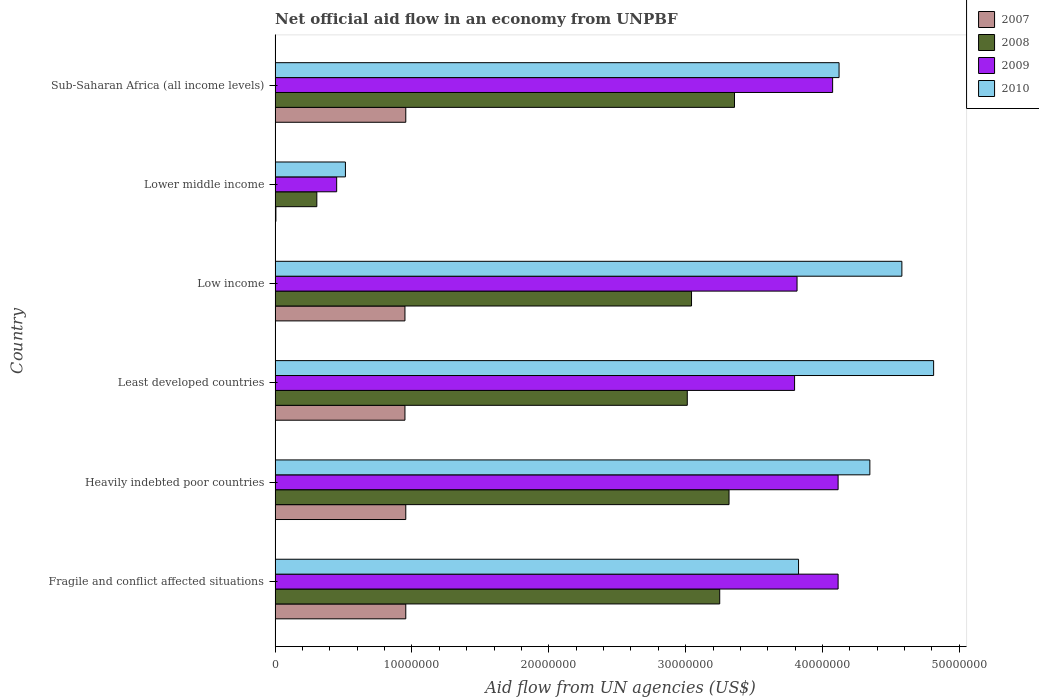Are the number of bars on each tick of the Y-axis equal?
Your answer should be very brief. Yes. How many bars are there on the 5th tick from the bottom?
Ensure brevity in your answer.  4. What is the label of the 2nd group of bars from the top?
Provide a succinct answer. Lower middle income. In how many cases, is the number of bars for a given country not equal to the number of legend labels?
Keep it short and to the point. 0. What is the net official aid flow in 2010 in Fragile and conflict affected situations?
Offer a terse response. 3.82e+07. Across all countries, what is the maximum net official aid flow in 2007?
Give a very brief answer. 9.55e+06. Across all countries, what is the minimum net official aid flow in 2010?
Your response must be concise. 5.14e+06. In which country was the net official aid flow in 2010 maximum?
Provide a succinct answer. Least developed countries. In which country was the net official aid flow in 2009 minimum?
Your answer should be compact. Lower middle income. What is the total net official aid flow in 2007 in the graph?
Ensure brevity in your answer.  4.77e+07. What is the difference between the net official aid flow in 2007 in Fragile and conflict affected situations and that in Low income?
Make the answer very short. 6.00e+04. What is the difference between the net official aid flow in 2010 in Fragile and conflict affected situations and the net official aid flow in 2008 in Least developed countries?
Keep it short and to the point. 8.13e+06. What is the average net official aid flow in 2010 per country?
Offer a very short reply. 3.70e+07. What is the difference between the net official aid flow in 2008 and net official aid flow in 2009 in Least developed countries?
Offer a terse response. -7.84e+06. What is the ratio of the net official aid flow in 2009 in Least developed countries to that in Lower middle income?
Give a very brief answer. 8.44. Is the difference between the net official aid flow in 2008 in Fragile and conflict affected situations and Low income greater than the difference between the net official aid flow in 2009 in Fragile and conflict affected situations and Low income?
Keep it short and to the point. No. What is the difference between the highest and the second highest net official aid flow in 2009?
Give a very brief answer. 0. What is the difference between the highest and the lowest net official aid flow in 2010?
Provide a succinct answer. 4.30e+07. In how many countries, is the net official aid flow in 2010 greater than the average net official aid flow in 2010 taken over all countries?
Offer a terse response. 5. Is the sum of the net official aid flow in 2010 in Fragile and conflict affected situations and Least developed countries greater than the maximum net official aid flow in 2009 across all countries?
Your answer should be very brief. Yes. Is it the case that in every country, the sum of the net official aid flow in 2009 and net official aid flow in 2008 is greater than the sum of net official aid flow in 2010 and net official aid flow in 2007?
Your response must be concise. No. What does the 3rd bar from the bottom in Lower middle income represents?
Your answer should be very brief. 2009. How many bars are there?
Provide a succinct answer. 24. What is the difference between two consecutive major ticks on the X-axis?
Offer a terse response. 1.00e+07. Are the values on the major ticks of X-axis written in scientific E-notation?
Keep it short and to the point. No. Where does the legend appear in the graph?
Provide a short and direct response. Top right. How many legend labels are there?
Ensure brevity in your answer.  4. How are the legend labels stacked?
Offer a terse response. Vertical. What is the title of the graph?
Offer a very short reply. Net official aid flow in an economy from UNPBF. What is the label or title of the X-axis?
Provide a short and direct response. Aid flow from UN agencies (US$). What is the Aid flow from UN agencies (US$) of 2007 in Fragile and conflict affected situations?
Your answer should be very brief. 9.55e+06. What is the Aid flow from UN agencies (US$) in 2008 in Fragile and conflict affected situations?
Keep it short and to the point. 3.25e+07. What is the Aid flow from UN agencies (US$) in 2009 in Fragile and conflict affected situations?
Give a very brief answer. 4.11e+07. What is the Aid flow from UN agencies (US$) of 2010 in Fragile and conflict affected situations?
Ensure brevity in your answer.  3.82e+07. What is the Aid flow from UN agencies (US$) in 2007 in Heavily indebted poor countries?
Offer a very short reply. 9.55e+06. What is the Aid flow from UN agencies (US$) in 2008 in Heavily indebted poor countries?
Provide a short and direct response. 3.32e+07. What is the Aid flow from UN agencies (US$) in 2009 in Heavily indebted poor countries?
Give a very brief answer. 4.11e+07. What is the Aid flow from UN agencies (US$) in 2010 in Heavily indebted poor countries?
Offer a very short reply. 4.35e+07. What is the Aid flow from UN agencies (US$) of 2007 in Least developed countries?
Ensure brevity in your answer.  9.49e+06. What is the Aid flow from UN agencies (US$) of 2008 in Least developed countries?
Your response must be concise. 3.01e+07. What is the Aid flow from UN agencies (US$) of 2009 in Least developed countries?
Give a very brief answer. 3.80e+07. What is the Aid flow from UN agencies (US$) of 2010 in Least developed countries?
Provide a short and direct response. 4.81e+07. What is the Aid flow from UN agencies (US$) of 2007 in Low income?
Provide a short and direct response. 9.49e+06. What is the Aid flow from UN agencies (US$) of 2008 in Low income?
Ensure brevity in your answer.  3.04e+07. What is the Aid flow from UN agencies (US$) in 2009 in Low income?
Keep it short and to the point. 3.81e+07. What is the Aid flow from UN agencies (US$) of 2010 in Low income?
Your answer should be very brief. 4.58e+07. What is the Aid flow from UN agencies (US$) in 2008 in Lower middle income?
Provide a short and direct response. 3.05e+06. What is the Aid flow from UN agencies (US$) in 2009 in Lower middle income?
Ensure brevity in your answer.  4.50e+06. What is the Aid flow from UN agencies (US$) in 2010 in Lower middle income?
Your answer should be very brief. 5.14e+06. What is the Aid flow from UN agencies (US$) of 2007 in Sub-Saharan Africa (all income levels)?
Make the answer very short. 9.55e+06. What is the Aid flow from UN agencies (US$) in 2008 in Sub-Saharan Africa (all income levels)?
Your answer should be compact. 3.36e+07. What is the Aid flow from UN agencies (US$) in 2009 in Sub-Saharan Africa (all income levels)?
Provide a succinct answer. 4.07e+07. What is the Aid flow from UN agencies (US$) of 2010 in Sub-Saharan Africa (all income levels)?
Offer a terse response. 4.12e+07. Across all countries, what is the maximum Aid flow from UN agencies (US$) in 2007?
Your answer should be compact. 9.55e+06. Across all countries, what is the maximum Aid flow from UN agencies (US$) in 2008?
Provide a succinct answer. 3.36e+07. Across all countries, what is the maximum Aid flow from UN agencies (US$) in 2009?
Offer a terse response. 4.11e+07. Across all countries, what is the maximum Aid flow from UN agencies (US$) of 2010?
Ensure brevity in your answer.  4.81e+07. Across all countries, what is the minimum Aid flow from UN agencies (US$) of 2007?
Offer a very short reply. 6.00e+04. Across all countries, what is the minimum Aid flow from UN agencies (US$) in 2008?
Offer a very short reply. 3.05e+06. Across all countries, what is the minimum Aid flow from UN agencies (US$) in 2009?
Provide a short and direct response. 4.50e+06. Across all countries, what is the minimum Aid flow from UN agencies (US$) in 2010?
Your answer should be very brief. 5.14e+06. What is the total Aid flow from UN agencies (US$) in 2007 in the graph?
Make the answer very short. 4.77e+07. What is the total Aid flow from UN agencies (US$) in 2008 in the graph?
Provide a short and direct response. 1.63e+08. What is the total Aid flow from UN agencies (US$) in 2009 in the graph?
Your response must be concise. 2.04e+08. What is the total Aid flow from UN agencies (US$) of 2010 in the graph?
Ensure brevity in your answer.  2.22e+08. What is the difference between the Aid flow from UN agencies (US$) of 2007 in Fragile and conflict affected situations and that in Heavily indebted poor countries?
Your answer should be very brief. 0. What is the difference between the Aid flow from UN agencies (US$) of 2008 in Fragile and conflict affected situations and that in Heavily indebted poor countries?
Give a very brief answer. -6.80e+05. What is the difference between the Aid flow from UN agencies (US$) in 2010 in Fragile and conflict affected situations and that in Heavily indebted poor countries?
Your answer should be compact. -5.21e+06. What is the difference between the Aid flow from UN agencies (US$) in 2008 in Fragile and conflict affected situations and that in Least developed countries?
Offer a very short reply. 2.37e+06. What is the difference between the Aid flow from UN agencies (US$) in 2009 in Fragile and conflict affected situations and that in Least developed countries?
Offer a terse response. 3.18e+06. What is the difference between the Aid flow from UN agencies (US$) of 2010 in Fragile and conflict affected situations and that in Least developed countries?
Offer a terse response. -9.87e+06. What is the difference between the Aid flow from UN agencies (US$) in 2008 in Fragile and conflict affected situations and that in Low income?
Offer a terse response. 2.06e+06. What is the difference between the Aid flow from UN agencies (US$) of 2009 in Fragile and conflict affected situations and that in Low income?
Your answer should be compact. 3.00e+06. What is the difference between the Aid flow from UN agencies (US$) of 2010 in Fragile and conflict affected situations and that in Low income?
Your response must be concise. -7.55e+06. What is the difference between the Aid flow from UN agencies (US$) in 2007 in Fragile and conflict affected situations and that in Lower middle income?
Keep it short and to the point. 9.49e+06. What is the difference between the Aid flow from UN agencies (US$) in 2008 in Fragile and conflict affected situations and that in Lower middle income?
Your answer should be compact. 2.94e+07. What is the difference between the Aid flow from UN agencies (US$) of 2009 in Fragile and conflict affected situations and that in Lower middle income?
Your answer should be compact. 3.66e+07. What is the difference between the Aid flow from UN agencies (US$) in 2010 in Fragile and conflict affected situations and that in Lower middle income?
Your answer should be compact. 3.31e+07. What is the difference between the Aid flow from UN agencies (US$) in 2007 in Fragile and conflict affected situations and that in Sub-Saharan Africa (all income levels)?
Your response must be concise. 0. What is the difference between the Aid flow from UN agencies (US$) in 2008 in Fragile and conflict affected situations and that in Sub-Saharan Africa (all income levels)?
Offer a very short reply. -1.08e+06. What is the difference between the Aid flow from UN agencies (US$) of 2009 in Fragile and conflict affected situations and that in Sub-Saharan Africa (all income levels)?
Give a very brief answer. 4.00e+05. What is the difference between the Aid flow from UN agencies (US$) in 2010 in Fragile and conflict affected situations and that in Sub-Saharan Africa (all income levels)?
Make the answer very short. -2.96e+06. What is the difference between the Aid flow from UN agencies (US$) in 2007 in Heavily indebted poor countries and that in Least developed countries?
Give a very brief answer. 6.00e+04. What is the difference between the Aid flow from UN agencies (US$) of 2008 in Heavily indebted poor countries and that in Least developed countries?
Give a very brief answer. 3.05e+06. What is the difference between the Aid flow from UN agencies (US$) of 2009 in Heavily indebted poor countries and that in Least developed countries?
Offer a very short reply. 3.18e+06. What is the difference between the Aid flow from UN agencies (US$) in 2010 in Heavily indebted poor countries and that in Least developed countries?
Provide a short and direct response. -4.66e+06. What is the difference between the Aid flow from UN agencies (US$) in 2007 in Heavily indebted poor countries and that in Low income?
Make the answer very short. 6.00e+04. What is the difference between the Aid flow from UN agencies (US$) in 2008 in Heavily indebted poor countries and that in Low income?
Keep it short and to the point. 2.74e+06. What is the difference between the Aid flow from UN agencies (US$) of 2010 in Heavily indebted poor countries and that in Low income?
Your response must be concise. -2.34e+06. What is the difference between the Aid flow from UN agencies (US$) in 2007 in Heavily indebted poor countries and that in Lower middle income?
Your response must be concise. 9.49e+06. What is the difference between the Aid flow from UN agencies (US$) in 2008 in Heavily indebted poor countries and that in Lower middle income?
Your answer should be very brief. 3.01e+07. What is the difference between the Aid flow from UN agencies (US$) of 2009 in Heavily indebted poor countries and that in Lower middle income?
Make the answer very short. 3.66e+07. What is the difference between the Aid flow from UN agencies (US$) in 2010 in Heavily indebted poor countries and that in Lower middle income?
Your answer should be very brief. 3.83e+07. What is the difference between the Aid flow from UN agencies (US$) in 2008 in Heavily indebted poor countries and that in Sub-Saharan Africa (all income levels)?
Your response must be concise. -4.00e+05. What is the difference between the Aid flow from UN agencies (US$) of 2010 in Heavily indebted poor countries and that in Sub-Saharan Africa (all income levels)?
Your answer should be very brief. 2.25e+06. What is the difference between the Aid flow from UN agencies (US$) of 2008 in Least developed countries and that in Low income?
Your response must be concise. -3.10e+05. What is the difference between the Aid flow from UN agencies (US$) in 2009 in Least developed countries and that in Low income?
Keep it short and to the point. -1.80e+05. What is the difference between the Aid flow from UN agencies (US$) in 2010 in Least developed countries and that in Low income?
Ensure brevity in your answer.  2.32e+06. What is the difference between the Aid flow from UN agencies (US$) in 2007 in Least developed countries and that in Lower middle income?
Ensure brevity in your answer.  9.43e+06. What is the difference between the Aid flow from UN agencies (US$) of 2008 in Least developed countries and that in Lower middle income?
Your answer should be very brief. 2.71e+07. What is the difference between the Aid flow from UN agencies (US$) of 2009 in Least developed countries and that in Lower middle income?
Provide a short and direct response. 3.35e+07. What is the difference between the Aid flow from UN agencies (US$) of 2010 in Least developed countries and that in Lower middle income?
Keep it short and to the point. 4.30e+07. What is the difference between the Aid flow from UN agencies (US$) in 2007 in Least developed countries and that in Sub-Saharan Africa (all income levels)?
Give a very brief answer. -6.00e+04. What is the difference between the Aid flow from UN agencies (US$) in 2008 in Least developed countries and that in Sub-Saharan Africa (all income levels)?
Make the answer very short. -3.45e+06. What is the difference between the Aid flow from UN agencies (US$) in 2009 in Least developed countries and that in Sub-Saharan Africa (all income levels)?
Your response must be concise. -2.78e+06. What is the difference between the Aid flow from UN agencies (US$) of 2010 in Least developed countries and that in Sub-Saharan Africa (all income levels)?
Provide a short and direct response. 6.91e+06. What is the difference between the Aid flow from UN agencies (US$) of 2007 in Low income and that in Lower middle income?
Your answer should be compact. 9.43e+06. What is the difference between the Aid flow from UN agencies (US$) in 2008 in Low income and that in Lower middle income?
Your answer should be very brief. 2.74e+07. What is the difference between the Aid flow from UN agencies (US$) of 2009 in Low income and that in Lower middle income?
Ensure brevity in your answer.  3.36e+07. What is the difference between the Aid flow from UN agencies (US$) in 2010 in Low income and that in Lower middle income?
Provide a short and direct response. 4.07e+07. What is the difference between the Aid flow from UN agencies (US$) in 2008 in Low income and that in Sub-Saharan Africa (all income levels)?
Ensure brevity in your answer.  -3.14e+06. What is the difference between the Aid flow from UN agencies (US$) in 2009 in Low income and that in Sub-Saharan Africa (all income levels)?
Your answer should be compact. -2.60e+06. What is the difference between the Aid flow from UN agencies (US$) in 2010 in Low income and that in Sub-Saharan Africa (all income levels)?
Offer a very short reply. 4.59e+06. What is the difference between the Aid flow from UN agencies (US$) in 2007 in Lower middle income and that in Sub-Saharan Africa (all income levels)?
Give a very brief answer. -9.49e+06. What is the difference between the Aid flow from UN agencies (US$) of 2008 in Lower middle income and that in Sub-Saharan Africa (all income levels)?
Offer a terse response. -3.05e+07. What is the difference between the Aid flow from UN agencies (US$) in 2009 in Lower middle income and that in Sub-Saharan Africa (all income levels)?
Keep it short and to the point. -3.62e+07. What is the difference between the Aid flow from UN agencies (US$) of 2010 in Lower middle income and that in Sub-Saharan Africa (all income levels)?
Give a very brief answer. -3.61e+07. What is the difference between the Aid flow from UN agencies (US$) in 2007 in Fragile and conflict affected situations and the Aid flow from UN agencies (US$) in 2008 in Heavily indebted poor countries?
Provide a short and direct response. -2.36e+07. What is the difference between the Aid flow from UN agencies (US$) in 2007 in Fragile and conflict affected situations and the Aid flow from UN agencies (US$) in 2009 in Heavily indebted poor countries?
Your answer should be compact. -3.16e+07. What is the difference between the Aid flow from UN agencies (US$) in 2007 in Fragile and conflict affected situations and the Aid flow from UN agencies (US$) in 2010 in Heavily indebted poor countries?
Provide a short and direct response. -3.39e+07. What is the difference between the Aid flow from UN agencies (US$) of 2008 in Fragile and conflict affected situations and the Aid flow from UN agencies (US$) of 2009 in Heavily indebted poor countries?
Your response must be concise. -8.65e+06. What is the difference between the Aid flow from UN agencies (US$) of 2008 in Fragile and conflict affected situations and the Aid flow from UN agencies (US$) of 2010 in Heavily indebted poor countries?
Offer a terse response. -1.10e+07. What is the difference between the Aid flow from UN agencies (US$) of 2009 in Fragile and conflict affected situations and the Aid flow from UN agencies (US$) of 2010 in Heavily indebted poor countries?
Make the answer very short. -2.32e+06. What is the difference between the Aid flow from UN agencies (US$) in 2007 in Fragile and conflict affected situations and the Aid flow from UN agencies (US$) in 2008 in Least developed countries?
Give a very brief answer. -2.06e+07. What is the difference between the Aid flow from UN agencies (US$) in 2007 in Fragile and conflict affected situations and the Aid flow from UN agencies (US$) in 2009 in Least developed countries?
Your answer should be compact. -2.84e+07. What is the difference between the Aid flow from UN agencies (US$) of 2007 in Fragile and conflict affected situations and the Aid flow from UN agencies (US$) of 2010 in Least developed countries?
Offer a very short reply. -3.86e+07. What is the difference between the Aid flow from UN agencies (US$) of 2008 in Fragile and conflict affected situations and the Aid flow from UN agencies (US$) of 2009 in Least developed countries?
Provide a short and direct response. -5.47e+06. What is the difference between the Aid flow from UN agencies (US$) in 2008 in Fragile and conflict affected situations and the Aid flow from UN agencies (US$) in 2010 in Least developed countries?
Ensure brevity in your answer.  -1.56e+07. What is the difference between the Aid flow from UN agencies (US$) of 2009 in Fragile and conflict affected situations and the Aid flow from UN agencies (US$) of 2010 in Least developed countries?
Provide a short and direct response. -6.98e+06. What is the difference between the Aid flow from UN agencies (US$) of 2007 in Fragile and conflict affected situations and the Aid flow from UN agencies (US$) of 2008 in Low income?
Make the answer very short. -2.09e+07. What is the difference between the Aid flow from UN agencies (US$) in 2007 in Fragile and conflict affected situations and the Aid flow from UN agencies (US$) in 2009 in Low income?
Offer a very short reply. -2.86e+07. What is the difference between the Aid flow from UN agencies (US$) in 2007 in Fragile and conflict affected situations and the Aid flow from UN agencies (US$) in 2010 in Low income?
Your answer should be compact. -3.62e+07. What is the difference between the Aid flow from UN agencies (US$) in 2008 in Fragile and conflict affected situations and the Aid flow from UN agencies (US$) in 2009 in Low income?
Keep it short and to the point. -5.65e+06. What is the difference between the Aid flow from UN agencies (US$) of 2008 in Fragile and conflict affected situations and the Aid flow from UN agencies (US$) of 2010 in Low income?
Your answer should be compact. -1.33e+07. What is the difference between the Aid flow from UN agencies (US$) of 2009 in Fragile and conflict affected situations and the Aid flow from UN agencies (US$) of 2010 in Low income?
Provide a short and direct response. -4.66e+06. What is the difference between the Aid flow from UN agencies (US$) in 2007 in Fragile and conflict affected situations and the Aid flow from UN agencies (US$) in 2008 in Lower middle income?
Offer a terse response. 6.50e+06. What is the difference between the Aid flow from UN agencies (US$) in 2007 in Fragile and conflict affected situations and the Aid flow from UN agencies (US$) in 2009 in Lower middle income?
Your answer should be very brief. 5.05e+06. What is the difference between the Aid flow from UN agencies (US$) of 2007 in Fragile and conflict affected situations and the Aid flow from UN agencies (US$) of 2010 in Lower middle income?
Give a very brief answer. 4.41e+06. What is the difference between the Aid flow from UN agencies (US$) in 2008 in Fragile and conflict affected situations and the Aid flow from UN agencies (US$) in 2009 in Lower middle income?
Make the answer very short. 2.80e+07. What is the difference between the Aid flow from UN agencies (US$) in 2008 in Fragile and conflict affected situations and the Aid flow from UN agencies (US$) in 2010 in Lower middle income?
Provide a succinct answer. 2.74e+07. What is the difference between the Aid flow from UN agencies (US$) of 2009 in Fragile and conflict affected situations and the Aid flow from UN agencies (US$) of 2010 in Lower middle income?
Offer a terse response. 3.60e+07. What is the difference between the Aid flow from UN agencies (US$) of 2007 in Fragile and conflict affected situations and the Aid flow from UN agencies (US$) of 2008 in Sub-Saharan Africa (all income levels)?
Your answer should be very brief. -2.40e+07. What is the difference between the Aid flow from UN agencies (US$) of 2007 in Fragile and conflict affected situations and the Aid flow from UN agencies (US$) of 2009 in Sub-Saharan Africa (all income levels)?
Offer a very short reply. -3.12e+07. What is the difference between the Aid flow from UN agencies (US$) in 2007 in Fragile and conflict affected situations and the Aid flow from UN agencies (US$) in 2010 in Sub-Saharan Africa (all income levels)?
Provide a succinct answer. -3.17e+07. What is the difference between the Aid flow from UN agencies (US$) of 2008 in Fragile and conflict affected situations and the Aid flow from UN agencies (US$) of 2009 in Sub-Saharan Africa (all income levels)?
Provide a succinct answer. -8.25e+06. What is the difference between the Aid flow from UN agencies (US$) of 2008 in Fragile and conflict affected situations and the Aid flow from UN agencies (US$) of 2010 in Sub-Saharan Africa (all income levels)?
Ensure brevity in your answer.  -8.72e+06. What is the difference between the Aid flow from UN agencies (US$) in 2007 in Heavily indebted poor countries and the Aid flow from UN agencies (US$) in 2008 in Least developed countries?
Provide a succinct answer. -2.06e+07. What is the difference between the Aid flow from UN agencies (US$) in 2007 in Heavily indebted poor countries and the Aid flow from UN agencies (US$) in 2009 in Least developed countries?
Provide a short and direct response. -2.84e+07. What is the difference between the Aid flow from UN agencies (US$) in 2007 in Heavily indebted poor countries and the Aid flow from UN agencies (US$) in 2010 in Least developed countries?
Provide a succinct answer. -3.86e+07. What is the difference between the Aid flow from UN agencies (US$) of 2008 in Heavily indebted poor countries and the Aid flow from UN agencies (US$) of 2009 in Least developed countries?
Ensure brevity in your answer.  -4.79e+06. What is the difference between the Aid flow from UN agencies (US$) in 2008 in Heavily indebted poor countries and the Aid flow from UN agencies (US$) in 2010 in Least developed countries?
Provide a succinct answer. -1.50e+07. What is the difference between the Aid flow from UN agencies (US$) of 2009 in Heavily indebted poor countries and the Aid flow from UN agencies (US$) of 2010 in Least developed countries?
Provide a succinct answer. -6.98e+06. What is the difference between the Aid flow from UN agencies (US$) in 2007 in Heavily indebted poor countries and the Aid flow from UN agencies (US$) in 2008 in Low income?
Make the answer very short. -2.09e+07. What is the difference between the Aid flow from UN agencies (US$) in 2007 in Heavily indebted poor countries and the Aid flow from UN agencies (US$) in 2009 in Low income?
Ensure brevity in your answer.  -2.86e+07. What is the difference between the Aid flow from UN agencies (US$) of 2007 in Heavily indebted poor countries and the Aid flow from UN agencies (US$) of 2010 in Low income?
Offer a very short reply. -3.62e+07. What is the difference between the Aid flow from UN agencies (US$) of 2008 in Heavily indebted poor countries and the Aid flow from UN agencies (US$) of 2009 in Low income?
Give a very brief answer. -4.97e+06. What is the difference between the Aid flow from UN agencies (US$) in 2008 in Heavily indebted poor countries and the Aid flow from UN agencies (US$) in 2010 in Low income?
Your answer should be very brief. -1.26e+07. What is the difference between the Aid flow from UN agencies (US$) of 2009 in Heavily indebted poor countries and the Aid flow from UN agencies (US$) of 2010 in Low income?
Your answer should be very brief. -4.66e+06. What is the difference between the Aid flow from UN agencies (US$) in 2007 in Heavily indebted poor countries and the Aid flow from UN agencies (US$) in 2008 in Lower middle income?
Provide a short and direct response. 6.50e+06. What is the difference between the Aid flow from UN agencies (US$) in 2007 in Heavily indebted poor countries and the Aid flow from UN agencies (US$) in 2009 in Lower middle income?
Your answer should be very brief. 5.05e+06. What is the difference between the Aid flow from UN agencies (US$) of 2007 in Heavily indebted poor countries and the Aid flow from UN agencies (US$) of 2010 in Lower middle income?
Your response must be concise. 4.41e+06. What is the difference between the Aid flow from UN agencies (US$) of 2008 in Heavily indebted poor countries and the Aid flow from UN agencies (US$) of 2009 in Lower middle income?
Give a very brief answer. 2.87e+07. What is the difference between the Aid flow from UN agencies (US$) of 2008 in Heavily indebted poor countries and the Aid flow from UN agencies (US$) of 2010 in Lower middle income?
Your answer should be very brief. 2.80e+07. What is the difference between the Aid flow from UN agencies (US$) in 2009 in Heavily indebted poor countries and the Aid flow from UN agencies (US$) in 2010 in Lower middle income?
Your answer should be very brief. 3.60e+07. What is the difference between the Aid flow from UN agencies (US$) in 2007 in Heavily indebted poor countries and the Aid flow from UN agencies (US$) in 2008 in Sub-Saharan Africa (all income levels)?
Ensure brevity in your answer.  -2.40e+07. What is the difference between the Aid flow from UN agencies (US$) in 2007 in Heavily indebted poor countries and the Aid flow from UN agencies (US$) in 2009 in Sub-Saharan Africa (all income levels)?
Offer a very short reply. -3.12e+07. What is the difference between the Aid flow from UN agencies (US$) in 2007 in Heavily indebted poor countries and the Aid flow from UN agencies (US$) in 2010 in Sub-Saharan Africa (all income levels)?
Your answer should be compact. -3.17e+07. What is the difference between the Aid flow from UN agencies (US$) in 2008 in Heavily indebted poor countries and the Aid flow from UN agencies (US$) in 2009 in Sub-Saharan Africa (all income levels)?
Keep it short and to the point. -7.57e+06. What is the difference between the Aid flow from UN agencies (US$) in 2008 in Heavily indebted poor countries and the Aid flow from UN agencies (US$) in 2010 in Sub-Saharan Africa (all income levels)?
Give a very brief answer. -8.04e+06. What is the difference between the Aid flow from UN agencies (US$) of 2007 in Least developed countries and the Aid flow from UN agencies (US$) of 2008 in Low income?
Keep it short and to the point. -2.09e+07. What is the difference between the Aid flow from UN agencies (US$) of 2007 in Least developed countries and the Aid flow from UN agencies (US$) of 2009 in Low income?
Make the answer very short. -2.86e+07. What is the difference between the Aid flow from UN agencies (US$) in 2007 in Least developed countries and the Aid flow from UN agencies (US$) in 2010 in Low income?
Offer a terse response. -3.63e+07. What is the difference between the Aid flow from UN agencies (US$) in 2008 in Least developed countries and the Aid flow from UN agencies (US$) in 2009 in Low income?
Ensure brevity in your answer.  -8.02e+06. What is the difference between the Aid flow from UN agencies (US$) of 2008 in Least developed countries and the Aid flow from UN agencies (US$) of 2010 in Low income?
Make the answer very short. -1.57e+07. What is the difference between the Aid flow from UN agencies (US$) in 2009 in Least developed countries and the Aid flow from UN agencies (US$) in 2010 in Low income?
Your answer should be very brief. -7.84e+06. What is the difference between the Aid flow from UN agencies (US$) in 2007 in Least developed countries and the Aid flow from UN agencies (US$) in 2008 in Lower middle income?
Give a very brief answer. 6.44e+06. What is the difference between the Aid flow from UN agencies (US$) of 2007 in Least developed countries and the Aid flow from UN agencies (US$) of 2009 in Lower middle income?
Offer a terse response. 4.99e+06. What is the difference between the Aid flow from UN agencies (US$) of 2007 in Least developed countries and the Aid flow from UN agencies (US$) of 2010 in Lower middle income?
Provide a succinct answer. 4.35e+06. What is the difference between the Aid flow from UN agencies (US$) of 2008 in Least developed countries and the Aid flow from UN agencies (US$) of 2009 in Lower middle income?
Provide a short and direct response. 2.56e+07. What is the difference between the Aid flow from UN agencies (US$) of 2008 in Least developed countries and the Aid flow from UN agencies (US$) of 2010 in Lower middle income?
Provide a succinct answer. 2.50e+07. What is the difference between the Aid flow from UN agencies (US$) in 2009 in Least developed countries and the Aid flow from UN agencies (US$) in 2010 in Lower middle income?
Your answer should be very brief. 3.28e+07. What is the difference between the Aid flow from UN agencies (US$) in 2007 in Least developed countries and the Aid flow from UN agencies (US$) in 2008 in Sub-Saharan Africa (all income levels)?
Your answer should be very brief. -2.41e+07. What is the difference between the Aid flow from UN agencies (US$) in 2007 in Least developed countries and the Aid flow from UN agencies (US$) in 2009 in Sub-Saharan Africa (all income levels)?
Offer a terse response. -3.12e+07. What is the difference between the Aid flow from UN agencies (US$) of 2007 in Least developed countries and the Aid flow from UN agencies (US$) of 2010 in Sub-Saharan Africa (all income levels)?
Give a very brief answer. -3.17e+07. What is the difference between the Aid flow from UN agencies (US$) in 2008 in Least developed countries and the Aid flow from UN agencies (US$) in 2009 in Sub-Saharan Africa (all income levels)?
Keep it short and to the point. -1.06e+07. What is the difference between the Aid flow from UN agencies (US$) of 2008 in Least developed countries and the Aid flow from UN agencies (US$) of 2010 in Sub-Saharan Africa (all income levels)?
Provide a succinct answer. -1.11e+07. What is the difference between the Aid flow from UN agencies (US$) of 2009 in Least developed countries and the Aid flow from UN agencies (US$) of 2010 in Sub-Saharan Africa (all income levels)?
Offer a very short reply. -3.25e+06. What is the difference between the Aid flow from UN agencies (US$) of 2007 in Low income and the Aid flow from UN agencies (US$) of 2008 in Lower middle income?
Provide a succinct answer. 6.44e+06. What is the difference between the Aid flow from UN agencies (US$) in 2007 in Low income and the Aid flow from UN agencies (US$) in 2009 in Lower middle income?
Offer a very short reply. 4.99e+06. What is the difference between the Aid flow from UN agencies (US$) in 2007 in Low income and the Aid flow from UN agencies (US$) in 2010 in Lower middle income?
Your answer should be very brief. 4.35e+06. What is the difference between the Aid flow from UN agencies (US$) in 2008 in Low income and the Aid flow from UN agencies (US$) in 2009 in Lower middle income?
Your answer should be compact. 2.59e+07. What is the difference between the Aid flow from UN agencies (US$) in 2008 in Low income and the Aid flow from UN agencies (US$) in 2010 in Lower middle income?
Provide a succinct answer. 2.53e+07. What is the difference between the Aid flow from UN agencies (US$) of 2009 in Low income and the Aid flow from UN agencies (US$) of 2010 in Lower middle income?
Give a very brief answer. 3.30e+07. What is the difference between the Aid flow from UN agencies (US$) of 2007 in Low income and the Aid flow from UN agencies (US$) of 2008 in Sub-Saharan Africa (all income levels)?
Give a very brief answer. -2.41e+07. What is the difference between the Aid flow from UN agencies (US$) of 2007 in Low income and the Aid flow from UN agencies (US$) of 2009 in Sub-Saharan Africa (all income levels)?
Provide a short and direct response. -3.12e+07. What is the difference between the Aid flow from UN agencies (US$) in 2007 in Low income and the Aid flow from UN agencies (US$) in 2010 in Sub-Saharan Africa (all income levels)?
Your answer should be compact. -3.17e+07. What is the difference between the Aid flow from UN agencies (US$) of 2008 in Low income and the Aid flow from UN agencies (US$) of 2009 in Sub-Saharan Africa (all income levels)?
Ensure brevity in your answer.  -1.03e+07. What is the difference between the Aid flow from UN agencies (US$) of 2008 in Low income and the Aid flow from UN agencies (US$) of 2010 in Sub-Saharan Africa (all income levels)?
Ensure brevity in your answer.  -1.08e+07. What is the difference between the Aid flow from UN agencies (US$) in 2009 in Low income and the Aid flow from UN agencies (US$) in 2010 in Sub-Saharan Africa (all income levels)?
Ensure brevity in your answer.  -3.07e+06. What is the difference between the Aid flow from UN agencies (US$) of 2007 in Lower middle income and the Aid flow from UN agencies (US$) of 2008 in Sub-Saharan Africa (all income levels)?
Give a very brief answer. -3.35e+07. What is the difference between the Aid flow from UN agencies (US$) of 2007 in Lower middle income and the Aid flow from UN agencies (US$) of 2009 in Sub-Saharan Africa (all income levels)?
Give a very brief answer. -4.07e+07. What is the difference between the Aid flow from UN agencies (US$) of 2007 in Lower middle income and the Aid flow from UN agencies (US$) of 2010 in Sub-Saharan Africa (all income levels)?
Ensure brevity in your answer.  -4.12e+07. What is the difference between the Aid flow from UN agencies (US$) in 2008 in Lower middle income and the Aid flow from UN agencies (US$) in 2009 in Sub-Saharan Africa (all income levels)?
Provide a succinct answer. -3.77e+07. What is the difference between the Aid flow from UN agencies (US$) in 2008 in Lower middle income and the Aid flow from UN agencies (US$) in 2010 in Sub-Saharan Africa (all income levels)?
Provide a succinct answer. -3.82e+07. What is the difference between the Aid flow from UN agencies (US$) of 2009 in Lower middle income and the Aid flow from UN agencies (US$) of 2010 in Sub-Saharan Africa (all income levels)?
Provide a short and direct response. -3.67e+07. What is the average Aid flow from UN agencies (US$) of 2007 per country?
Provide a short and direct response. 7.95e+06. What is the average Aid flow from UN agencies (US$) in 2008 per country?
Your answer should be compact. 2.71e+07. What is the average Aid flow from UN agencies (US$) in 2009 per country?
Offer a terse response. 3.39e+07. What is the average Aid flow from UN agencies (US$) of 2010 per country?
Keep it short and to the point. 3.70e+07. What is the difference between the Aid flow from UN agencies (US$) of 2007 and Aid flow from UN agencies (US$) of 2008 in Fragile and conflict affected situations?
Ensure brevity in your answer.  -2.29e+07. What is the difference between the Aid flow from UN agencies (US$) in 2007 and Aid flow from UN agencies (US$) in 2009 in Fragile and conflict affected situations?
Your answer should be very brief. -3.16e+07. What is the difference between the Aid flow from UN agencies (US$) in 2007 and Aid flow from UN agencies (US$) in 2010 in Fragile and conflict affected situations?
Your answer should be compact. -2.87e+07. What is the difference between the Aid flow from UN agencies (US$) of 2008 and Aid flow from UN agencies (US$) of 2009 in Fragile and conflict affected situations?
Provide a succinct answer. -8.65e+06. What is the difference between the Aid flow from UN agencies (US$) in 2008 and Aid flow from UN agencies (US$) in 2010 in Fragile and conflict affected situations?
Give a very brief answer. -5.76e+06. What is the difference between the Aid flow from UN agencies (US$) in 2009 and Aid flow from UN agencies (US$) in 2010 in Fragile and conflict affected situations?
Your answer should be very brief. 2.89e+06. What is the difference between the Aid flow from UN agencies (US$) of 2007 and Aid flow from UN agencies (US$) of 2008 in Heavily indebted poor countries?
Your answer should be compact. -2.36e+07. What is the difference between the Aid flow from UN agencies (US$) of 2007 and Aid flow from UN agencies (US$) of 2009 in Heavily indebted poor countries?
Keep it short and to the point. -3.16e+07. What is the difference between the Aid flow from UN agencies (US$) of 2007 and Aid flow from UN agencies (US$) of 2010 in Heavily indebted poor countries?
Ensure brevity in your answer.  -3.39e+07. What is the difference between the Aid flow from UN agencies (US$) of 2008 and Aid flow from UN agencies (US$) of 2009 in Heavily indebted poor countries?
Provide a short and direct response. -7.97e+06. What is the difference between the Aid flow from UN agencies (US$) of 2008 and Aid flow from UN agencies (US$) of 2010 in Heavily indebted poor countries?
Offer a very short reply. -1.03e+07. What is the difference between the Aid flow from UN agencies (US$) in 2009 and Aid flow from UN agencies (US$) in 2010 in Heavily indebted poor countries?
Offer a terse response. -2.32e+06. What is the difference between the Aid flow from UN agencies (US$) of 2007 and Aid flow from UN agencies (US$) of 2008 in Least developed countries?
Make the answer very short. -2.06e+07. What is the difference between the Aid flow from UN agencies (US$) of 2007 and Aid flow from UN agencies (US$) of 2009 in Least developed countries?
Give a very brief answer. -2.85e+07. What is the difference between the Aid flow from UN agencies (US$) in 2007 and Aid flow from UN agencies (US$) in 2010 in Least developed countries?
Offer a terse response. -3.86e+07. What is the difference between the Aid flow from UN agencies (US$) of 2008 and Aid flow from UN agencies (US$) of 2009 in Least developed countries?
Offer a very short reply. -7.84e+06. What is the difference between the Aid flow from UN agencies (US$) of 2008 and Aid flow from UN agencies (US$) of 2010 in Least developed countries?
Give a very brief answer. -1.80e+07. What is the difference between the Aid flow from UN agencies (US$) of 2009 and Aid flow from UN agencies (US$) of 2010 in Least developed countries?
Your answer should be very brief. -1.02e+07. What is the difference between the Aid flow from UN agencies (US$) in 2007 and Aid flow from UN agencies (US$) in 2008 in Low income?
Provide a short and direct response. -2.09e+07. What is the difference between the Aid flow from UN agencies (US$) in 2007 and Aid flow from UN agencies (US$) in 2009 in Low income?
Keep it short and to the point. -2.86e+07. What is the difference between the Aid flow from UN agencies (US$) in 2007 and Aid flow from UN agencies (US$) in 2010 in Low income?
Ensure brevity in your answer.  -3.63e+07. What is the difference between the Aid flow from UN agencies (US$) of 2008 and Aid flow from UN agencies (US$) of 2009 in Low income?
Ensure brevity in your answer.  -7.71e+06. What is the difference between the Aid flow from UN agencies (US$) in 2008 and Aid flow from UN agencies (US$) in 2010 in Low income?
Your response must be concise. -1.54e+07. What is the difference between the Aid flow from UN agencies (US$) in 2009 and Aid flow from UN agencies (US$) in 2010 in Low income?
Give a very brief answer. -7.66e+06. What is the difference between the Aid flow from UN agencies (US$) in 2007 and Aid flow from UN agencies (US$) in 2008 in Lower middle income?
Ensure brevity in your answer.  -2.99e+06. What is the difference between the Aid flow from UN agencies (US$) of 2007 and Aid flow from UN agencies (US$) of 2009 in Lower middle income?
Make the answer very short. -4.44e+06. What is the difference between the Aid flow from UN agencies (US$) in 2007 and Aid flow from UN agencies (US$) in 2010 in Lower middle income?
Give a very brief answer. -5.08e+06. What is the difference between the Aid flow from UN agencies (US$) in 2008 and Aid flow from UN agencies (US$) in 2009 in Lower middle income?
Your response must be concise. -1.45e+06. What is the difference between the Aid flow from UN agencies (US$) of 2008 and Aid flow from UN agencies (US$) of 2010 in Lower middle income?
Ensure brevity in your answer.  -2.09e+06. What is the difference between the Aid flow from UN agencies (US$) in 2009 and Aid flow from UN agencies (US$) in 2010 in Lower middle income?
Offer a very short reply. -6.40e+05. What is the difference between the Aid flow from UN agencies (US$) of 2007 and Aid flow from UN agencies (US$) of 2008 in Sub-Saharan Africa (all income levels)?
Keep it short and to the point. -2.40e+07. What is the difference between the Aid flow from UN agencies (US$) of 2007 and Aid flow from UN agencies (US$) of 2009 in Sub-Saharan Africa (all income levels)?
Make the answer very short. -3.12e+07. What is the difference between the Aid flow from UN agencies (US$) of 2007 and Aid flow from UN agencies (US$) of 2010 in Sub-Saharan Africa (all income levels)?
Provide a short and direct response. -3.17e+07. What is the difference between the Aid flow from UN agencies (US$) of 2008 and Aid flow from UN agencies (US$) of 2009 in Sub-Saharan Africa (all income levels)?
Make the answer very short. -7.17e+06. What is the difference between the Aid flow from UN agencies (US$) in 2008 and Aid flow from UN agencies (US$) in 2010 in Sub-Saharan Africa (all income levels)?
Offer a terse response. -7.64e+06. What is the difference between the Aid flow from UN agencies (US$) in 2009 and Aid flow from UN agencies (US$) in 2010 in Sub-Saharan Africa (all income levels)?
Give a very brief answer. -4.70e+05. What is the ratio of the Aid flow from UN agencies (US$) in 2008 in Fragile and conflict affected situations to that in Heavily indebted poor countries?
Your response must be concise. 0.98. What is the ratio of the Aid flow from UN agencies (US$) of 2009 in Fragile and conflict affected situations to that in Heavily indebted poor countries?
Ensure brevity in your answer.  1. What is the ratio of the Aid flow from UN agencies (US$) in 2010 in Fragile and conflict affected situations to that in Heavily indebted poor countries?
Ensure brevity in your answer.  0.88. What is the ratio of the Aid flow from UN agencies (US$) of 2008 in Fragile and conflict affected situations to that in Least developed countries?
Your response must be concise. 1.08. What is the ratio of the Aid flow from UN agencies (US$) of 2009 in Fragile and conflict affected situations to that in Least developed countries?
Ensure brevity in your answer.  1.08. What is the ratio of the Aid flow from UN agencies (US$) in 2010 in Fragile and conflict affected situations to that in Least developed countries?
Offer a terse response. 0.79. What is the ratio of the Aid flow from UN agencies (US$) of 2007 in Fragile and conflict affected situations to that in Low income?
Make the answer very short. 1.01. What is the ratio of the Aid flow from UN agencies (US$) of 2008 in Fragile and conflict affected situations to that in Low income?
Your answer should be compact. 1.07. What is the ratio of the Aid flow from UN agencies (US$) in 2009 in Fragile and conflict affected situations to that in Low income?
Provide a succinct answer. 1.08. What is the ratio of the Aid flow from UN agencies (US$) in 2010 in Fragile and conflict affected situations to that in Low income?
Give a very brief answer. 0.84. What is the ratio of the Aid flow from UN agencies (US$) in 2007 in Fragile and conflict affected situations to that in Lower middle income?
Make the answer very short. 159.17. What is the ratio of the Aid flow from UN agencies (US$) of 2008 in Fragile and conflict affected situations to that in Lower middle income?
Offer a very short reply. 10.65. What is the ratio of the Aid flow from UN agencies (US$) of 2009 in Fragile and conflict affected situations to that in Lower middle income?
Provide a short and direct response. 9.14. What is the ratio of the Aid flow from UN agencies (US$) of 2010 in Fragile and conflict affected situations to that in Lower middle income?
Make the answer very short. 7.44. What is the ratio of the Aid flow from UN agencies (US$) of 2008 in Fragile and conflict affected situations to that in Sub-Saharan Africa (all income levels)?
Give a very brief answer. 0.97. What is the ratio of the Aid flow from UN agencies (US$) in 2009 in Fragile and conflict affected situations to that in Sub-Saharan Africa (all income levels)?
Your response must be concise. 1.01. What is the ratio of the Aid flow from UN agencies (US$) in 2010 in Fragile and conflict affected situations to that in Sub-Saharan Africa (all income levels)?
Provide a short and direct response. 0.93. What is the ratio of the Aid flow from UN agencies (US$) of 2008 in Heavily indebted poor countries to that in Least developed countries?
Keep it short and to the point. 1.1. What is the ratio of the Aid flow from UN agencies (US$) in 2009 in Heavily indebted poor countries to that in Least developed countries?
Provide a short and direct response. 1.08. What is the ratio of the Aid flow from UN agencies (US$) in 2010 in Heavily indebted poor countries to that in Least developed countries?
Make the answer very short. 0.9. What is the ratio of the Aid flow from UN agencies (US$) in 2008 in Heavily indebted poor countries to that in Low income?
Provide a short and direct response. 1.09. What is the ratio of the Aid flow from UN agencies (US$) in 2009 in Heavily indebted poor countries to that in Low income?
Give a very brief answer. 1.08. What is the ratio of the Aid flow from UN agencies (US$) in 2010 in Heavily indebted poor countries to that in Low income?
Offer a terse response. 0.95. What is the ratio of the Aid flow from UN agencies (US$) of 2007 in Heavily indebted poor countries to that in Lower middle income?
Your answer should be very brief. 159.17. What is the ratio of the Aid flow from UN agencies (US$) of 2008 in Heavily indebted poor countries to that in Lower middle income?
Your response must be concise. 10.88. What is the ratio of the Aid flow from UN agencies (US$) of 2009 in Heavily indebted poor countries to that in Lower middle income?
Give a very brief answer. 9.14. What is the ratio of the Aid flow from UN agencies (US$) of 2010 in Heavily indebted poor countries to that in Lower middle income?
Keep it short and to the point. 8.46. What is the ratio of the Aid flow from UN agencies (US$) in 2009 in Heavily indebted poor countries to that in Sub-Saharan Africa (all income levels)?
Your answer should be very brief. 1.01. What is the ratio of the Aid flow from UN agencies (US$) in 2010 in Heavily indebted poor countries to that in Sub-Saharan Africa (all income levels)?
Your response must be concise. 1.05. What is the ratio of the Aid flow from UN agencies (US$) in 2009 in Least developed countries to that in Low income?
Ensure brevity in your answer.  1. What is the ratio of the Aid flow from UN agencies (US$) of 2010 in Least developed countries to that in Low income?
Your response must be concise. 1.05. What is the ratio of the Aid flow from UN agencies (US$) of 2007 in Least developed countries to that in Lower middle income?
Provide a succinct answer. 158.17. What is the ratio of the Aid flow from UN agencies (US$) in 2008 in Least developed countries to that in Lower middle income?
Provide a short and direct response. 9.88. What is the ratio of the Aid flow from UN agencies (US$) of 2009 in Least developed countries to that in Lower middle income?
Offer a terse response. 8.44. What is the ratio of the Aid flow from UN agencies (US$) of 2010 in Least developed countries to that in Lower middle income?
Provide a succinct answer. 9.36. What is the ratio of the Aid flow from UN agencies (US$) of 2008 in Least developed countries to that in Sub-Saharan Africa (all income levels)?
Ensure brevity in your answer.  0.9. What is the ratio of the Aid flow from UN agencies (US$) in 2009 in Least developed countries to that in Sub-Saharan Africa (all income levels)?
Make the answer very short. 0.93. What is the ratio of the Aid flow from UN agencies (US$) in 2010 in Least developed countries to that in Sub-Saharan Africa (all income levels)?
Provide a succinct answer. 1.17. What is the ratio of the Aid flow from UN agencies (US$) of 2007 in Low income to that in Lower middle income?
Make the answer very short. 158.17. What is the ratio of the Aid flow from UN agencies (US$) in 2008 in Low income to that in Lower middle income?
Keep it short and to the point. 9.98. What is the ratio of the Aid flow from UN agencies (US$) of 2009 in Low income to that in Lower middle income?
Ensure brevity in your answer.  8.48. What is the ratio of the Aid flow from UN agencies (US$) of 2010 in Low income to that in Lower middle income?
Give a very brief answer. 8.91. What is the ratio of the Aid flow from UN agencies (US$) in 2008 in Low income to that in Sub-Saharan Africa (all income levels)?
Make the answer very short. 0.91. What is the ratio of the Aid flow from UN agencies (US$) in 2009 in Low income to that in Sub-Saharan Africa (all income levels)?
Offer a very short reply. 0.94. What is the ratio of the Aid flow from UN agencies (US$) of 2010 in Low income to that in Sub-Saharan Africa (all income levels)?
Provide a short and direct response. 1.11. What is the ratio of the Aid flow from UN agencies (US$) of 2007 in Lower middle income to that in Sub-Saharan Africa (all income levels)?
Offer a terse response. 0.01. What is the ratio of the Aid flow from UN agencies (US$) of 2008 in Lower middle income to that in Sub-Saharan Africa (all income levels)?
Keep it short and to the point. 0.09. What is the ratio of the Aid flow from UN agencies (US$) of 2009 in Lower middle income to that in Sub-Saharan Africa (all income levels)?
Keep it short and to the point. 0.11. What is the ratio of the Aid flow from UN agencies (US$) in 2010 in Lower middle income to that in Sub-Saharan Africa (all income levels)?
Provide a short and direct response. 0.12. What is the difference between the highest and the second highest Aid flow from UN agencies (US$) in 2008?
Provide a short and direct response. 4.00e+05. What is the difference between the highest and the second highest Aid flow from UN agencies (US$) of 2009?
Provide a succinct answer. 0. What is the difference between the highest and the second highest Aid flow from UN agencies (US$) of 2010?
Offer a terse response. 2.32e+06. What is the difference between the highest and the lowest Aid flow from UN agencies (US$) in 2007?
Give a very brief answer. 9.49e+06. What is the difference between the highest and the lowest Aid flow from UN agencies (US$) in 2008?
Provide a succinct answer. 3.05e+07. What is the difference between the highest and the lowest Aid flow from UN agencies (US$) of 2009?
Provide a short and direct response. 3.66e+07. What is the difference between the highest and the lowest Aid flow from UN agencies (US$) of 2010?
Your response must be concise. 4.30e+07. 